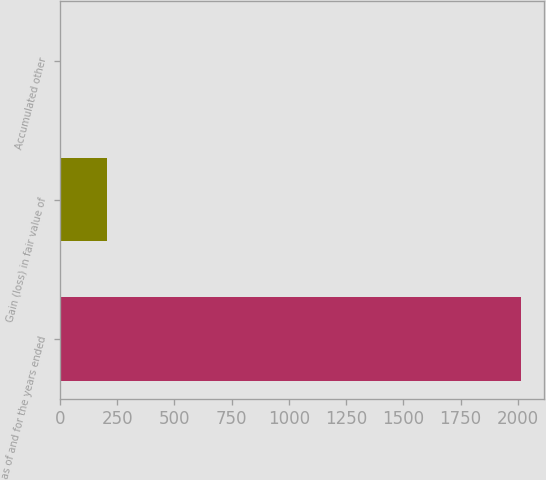Convert chart. <chart><loc_0><loc_0><loc_500><loc_500><bar_chart><fcel>as of and for the years ended<fcel>Gain (loss) in fair value of<fcel>Accumulated other<nl><fcel>2012<fcel>205.7<fcel>5<nl></chart> 